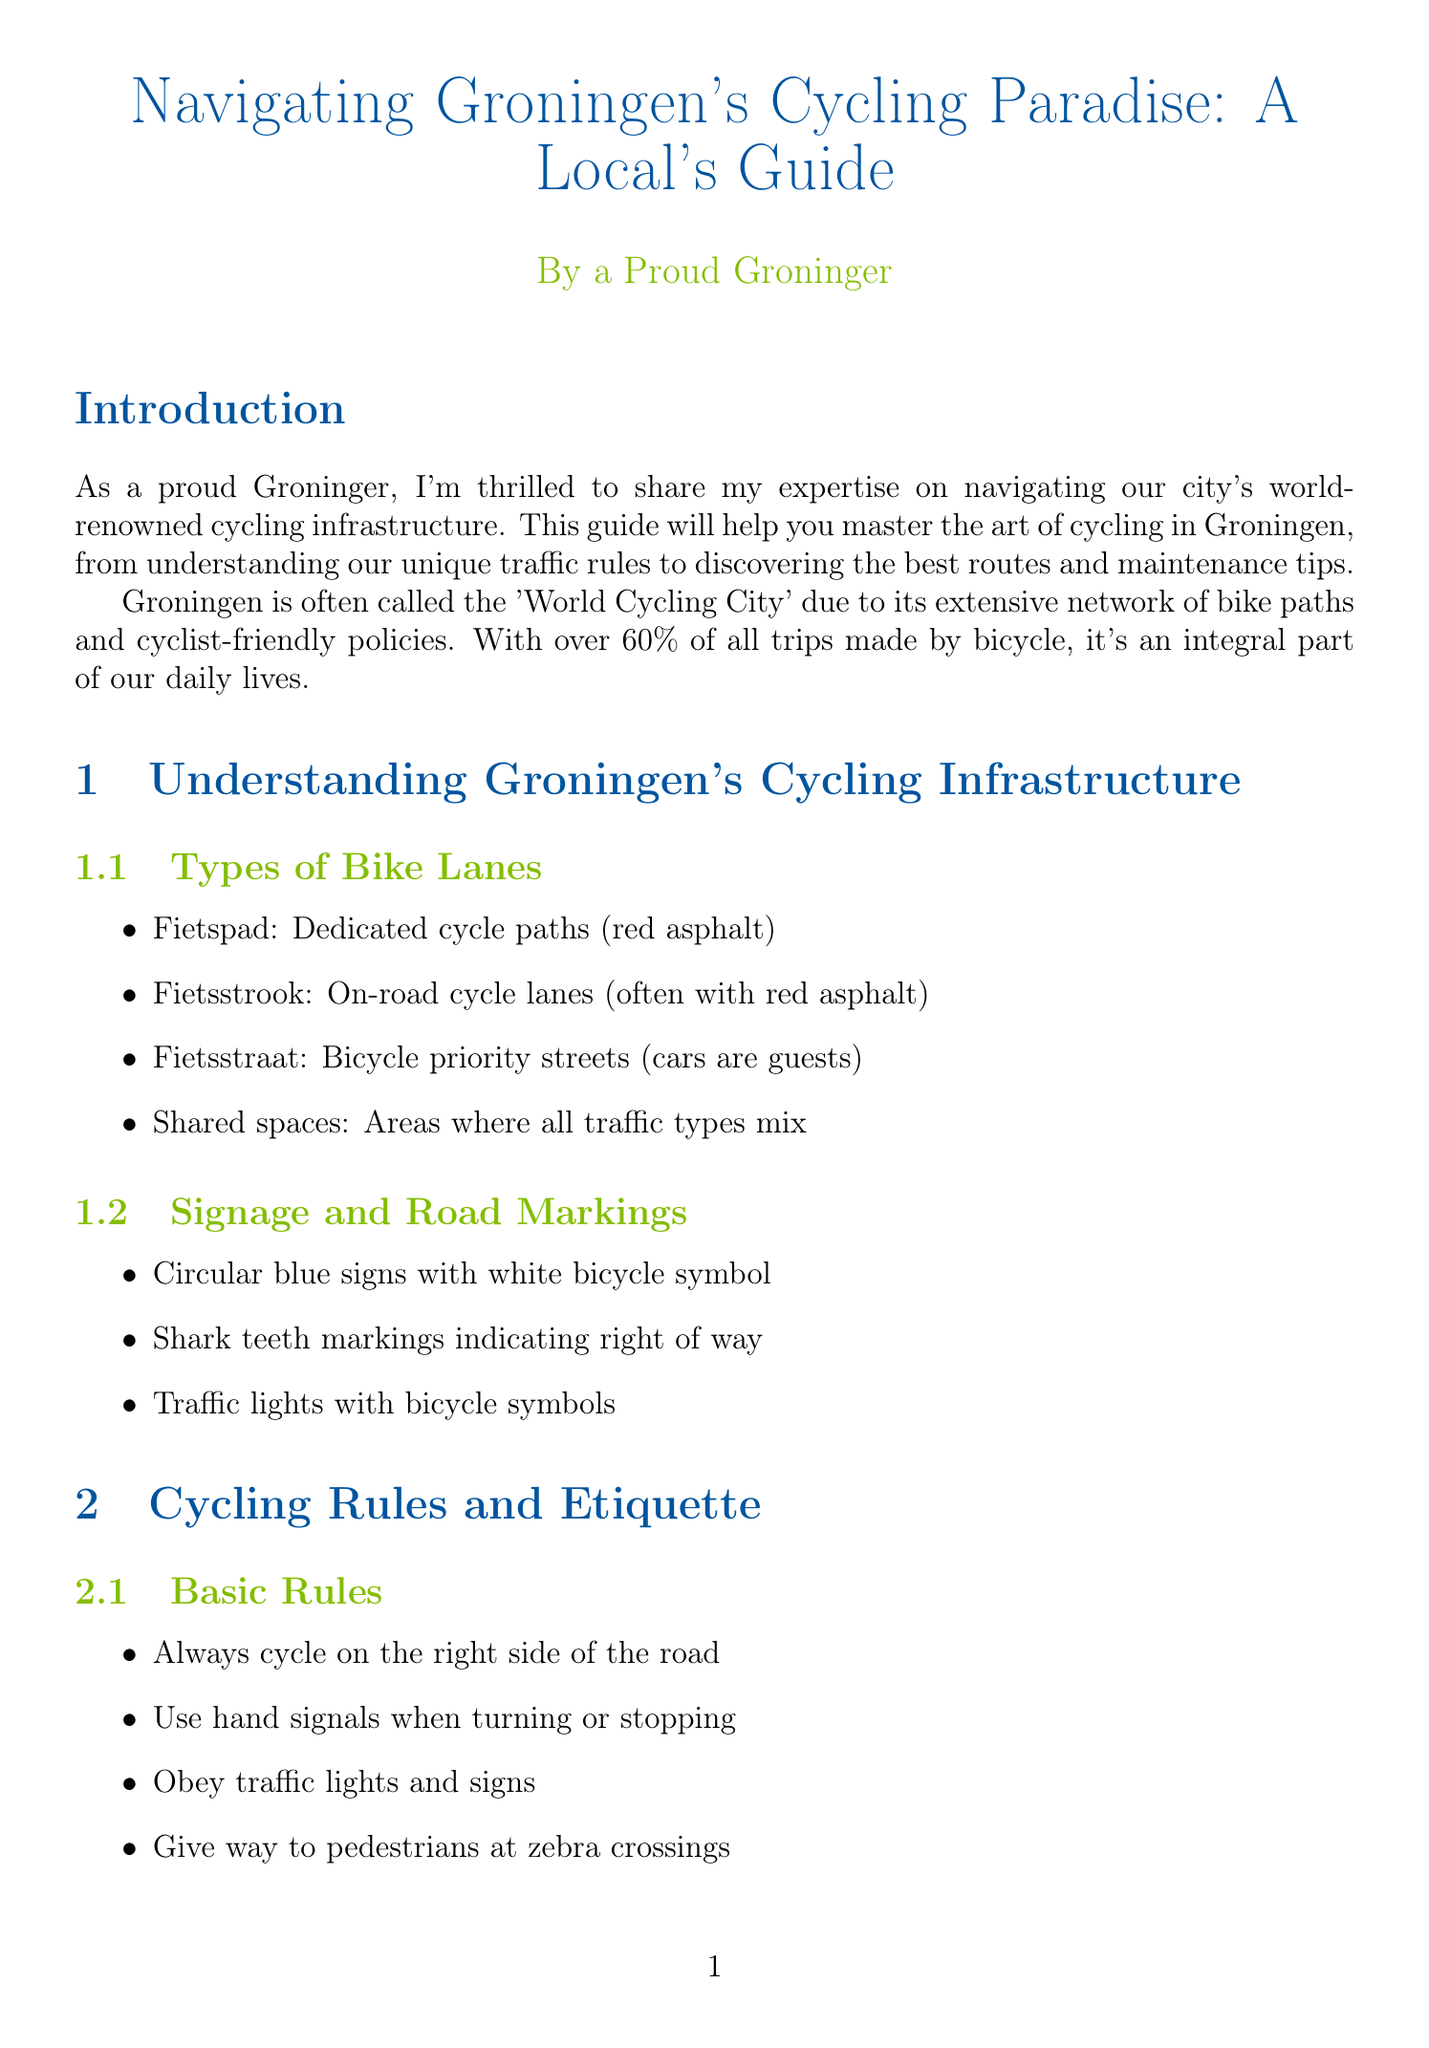What is the title of the guide? The title of the guide as stated in the document is the main heading at the top of the document.
Answer: Navigating Groningen's Cycling Paradise: A Local's Guide What percentage of trips in Groningen are made by bicycle? The percentage mentioned in the introduction highlights the significance of cycling in Groningen's daily life.
Answer: 60% What does 'fietsstraat' refer to? The term 'fietsstraat' appears in the section about types of bike lanes and indicates a specific type of roadway.
Answer: Bicycle priority streets (cars are guests) Which location has a large underground bicycle parking? The document lists various locations for bike parking and one of them is specified as having a large facility.
Answer: Hoofdstation What event occurs in June related to cycling? The annual cycling event mentioned in the cycling events section is specifically highlighted by its month and nature.
Answer: Fiets4Daagse What type of maintenance tips are provided for Groningen's weather? The document offers maintenance advice tailored to local weather conditions, found under bicycle maintenance.
Answer: Regular maintenance tips for Groningen's weather conditions Who is an advocacy group for cyclists in Groningen? The cycling groups section lists organizations that focus on cyclists' rights and advocacy.
Answer: Fietsersbond Groningen What is one of the recommended routes in the document? The popular cycling routes section outlines specific cycling paths, including one that begins at a landmark.
Answer: City Center Loop 